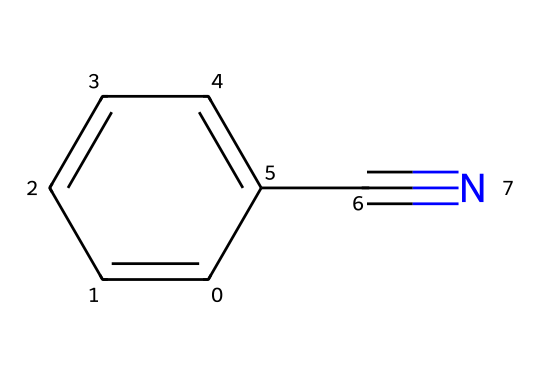What is the common name for c1ccccc1C#N? The SMILES representation indicates this is benzonitrile, which contains a phenyl ring and a nitrile group.
Answer: benzonitrile How many carbon atoms are in benzonitrile? Analyzing the SMILES, I count six carbon atoms in the benzene ring and one additional carbon in the nitrile group, resulting in a total of seven carbon atoms.
Answer: seven What functional group is present in benzonitrile? The structure shows a carbon triple-bonded to a nitrogen, which defines the nitrile functional group.
Answer: nitrile What is the degree of unsaturation in benzonitrile? The benzene ring contributes four degrees of unsaturation, while the nitrile contributes one more, leading to a total of five degrees of unsaturation for the entire molecule.
Answer: five Is benzonitrile polar or nonpolar? The presence of the nitrile (–C#N) group creates a polar bond due to the difference in electronegativity between carbon and nitrogen, indicating that the molecule is polar overall.
Answer: polar What type of reaction could benzonitrile undergo to produce a carboxylic acid? Benzonitrile can undergo hydrolysis to convert the nitrile group into a carboxylic acid group (-COOH), which is a common transformation in organic chemistry.
Answer: hydrolysis 